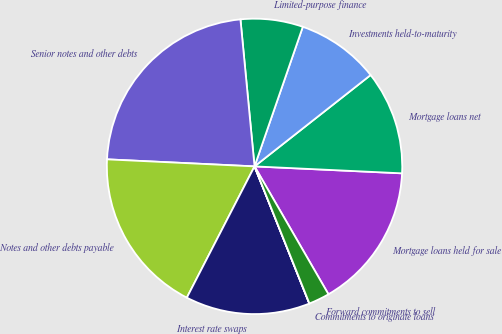Convert chart. <chart><loc_0><loc_0><loc_500><loc_500><pie_chart><fcel>Mortgage loans held for sale<fcel>Mortgage loans net<fcel>Investments held-to-maturity<fcel>Limited-purpose finance<fcel>Senior notes and other debts<fcel>Notes and other debts payable<fcel>Interest rate swaps<fcel>Commitments to originate loans<fcel>Forward commitments to sell<nl><fcel>15.91%<fcel>11.36%<fcel>9.09%<fcel>6.82%<fcel>22.72%<fcel>18.18%<fcel>13.63%<fcel>0.01%<fcel>2.28%<nl></chart> 